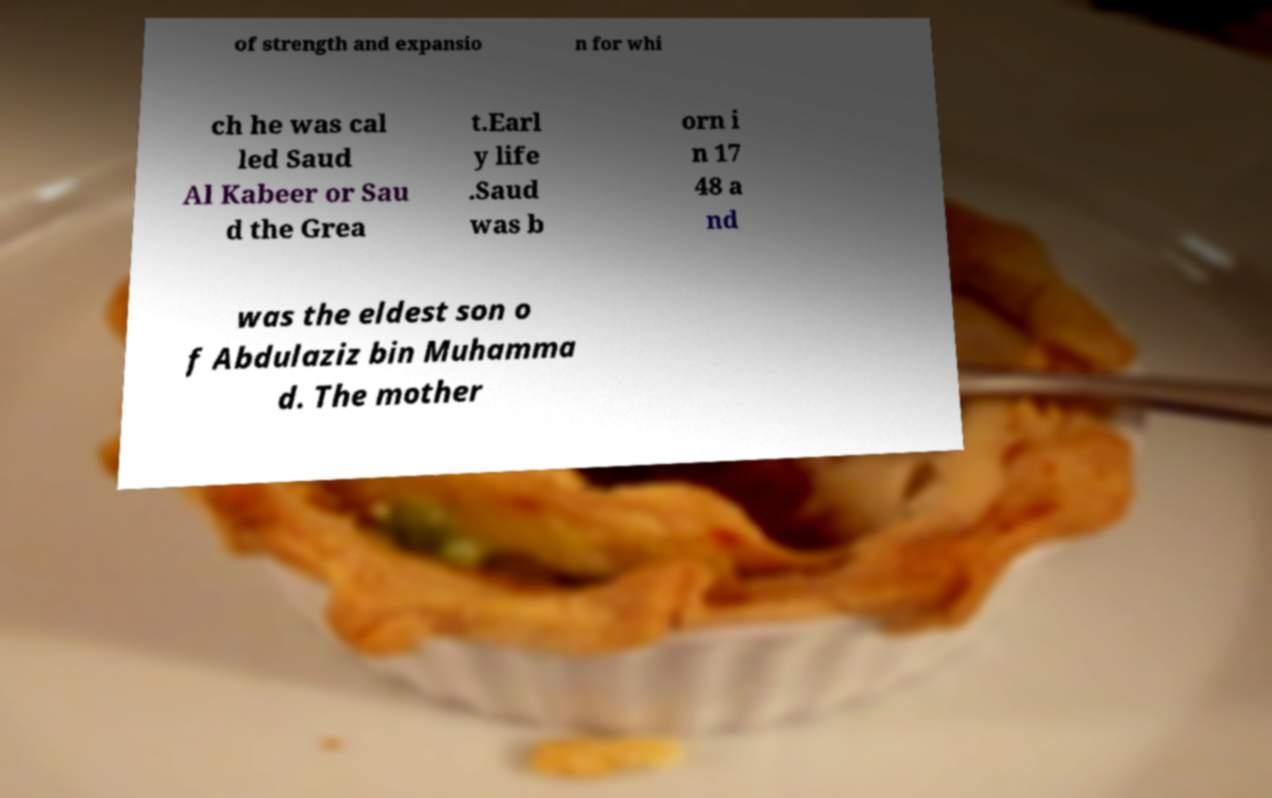For documentation purposes, I need the text within this image transcribed. Could you provide that? of strength and expansio n for whi ch he was cal led Saud Al Kabeer or Sau d the Grea t.Earl y life .Saud was b orn i n 17 48 a nd was the eldest son o f Abdulaziz bin Muhamma d. The mother 